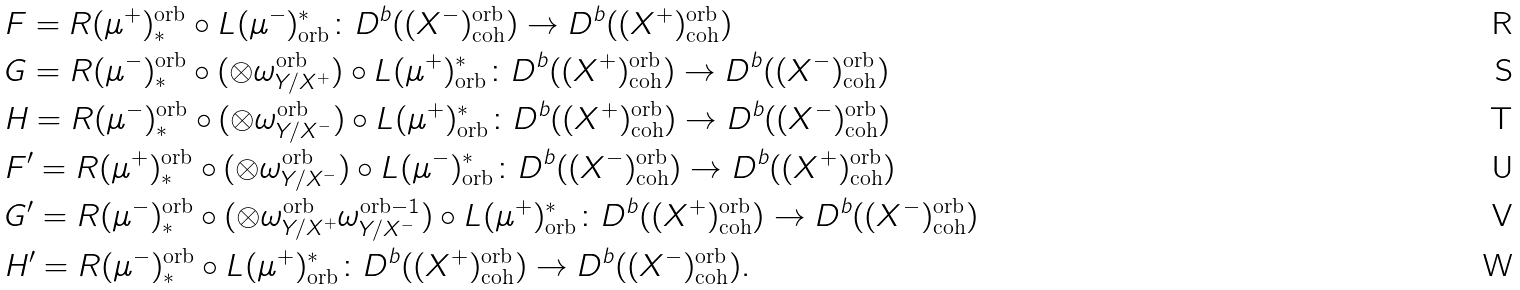<formula> <loc_0><loc_0><loc_500><loc_500>& F = R ( \mu ^ { + } ) _ { * } ^ { \text {orb} } \circ L ( \mu ^ { - } ) ^ { * } _ { \text {orb} } \colon D ^ { b } ( ( X ^ { - } ) _ { \text {coh} } ^ { \text {orb} } ) \to D ^ { b } ( ( X ^ { + } ) _ { \text {coh} } ^ { \text {orb} } ) \\ & G = R ( \mu ^ { - } ) _ { * } ^ { \text {orb} } \circ ( \otimes \omega _ { Y / X ^ { + } } ^ { \text {orb} } ) \circ L ( \mu ^ { + } ) ^ { * } _ { \text {orb} } \colon D ^ { b } ( ( X ^ { + } ) _ { \text {coh} } ^ { \text {orb} } ) \to D ^ { b } ( ( X ^ { - } ) _ { \text {coh} } ^ { \text {orb} } ) \\ & H = R ( \mu ^ { - } ) _ { * } ^ { \text {orb} } \circ ( \otimes \omega _ { Y / X ^ { - } } ^ { \text {orb} } ) \circ L ( \mu ^ { + } ) ^ { * } _ { \text {orb} } \colon D ^ { b } ( ( X ^ { + } ) _ { \text {coh} } ^ { \text {orb} } ) \to D ^ { b } ( ( X ^ { - } ) _ { \text {coh} } ^ { \text {orb} } ) \\ & F ^ { \prime } = R ( \mu ^ { + } ) _ { * } ^ { \text {orb} } \circ ( \otimes \omega _ { Y / X ^ { - } } ^ { \text {orb} } ) \circ L ( \mu ^ { - } ) ^ { * } _ { \text {orb} } \colon D ^ { b } ( ( X ^ { - } ) _ { \text {coh} } ^ { \text {orb} } ) \to D ^ { b } ( ( X ^ { + } ) _ { \text {coh} } ^ { \text {orb} } ) \\ & G ^ { \prime } = R ( \mu ^ { - } ) _ { * } ^ { \text {orb} } \circ ( \otimes \omega _ { Y / X ^ { + } } ^ { \text {orb} } \omega _ { Y / X ^ { - } } ^ { \text {orb} - 1 } ) \circ L ( \mu ^ { + } ) ^ { * } _ { \text {orb} } \colon D ^ { b } ( ( X ^ { + } ) _ { \text {coh} } ^ { \text {orb} } ) \to D ^ { b } ( ( X ^ { - } ) _ { \text {coh} } ^ { \text {orb} } ) \\ & H ^ { \prime } = R ( \mu ^ { - } ) _ { * } ^ { \text {orb} } \circ L ( \mu ^ { + } ) ^ { * } _ { \text {orb} } \colon D ^ { b } ( ( X ^ { + } ) _ { \text {coh} } ^ { \text {orb} } ) \to D ^ { b } ( ( X ^ { - } ) _ { \text {coh} } ^ { \text {orb} } ) .</formula> 